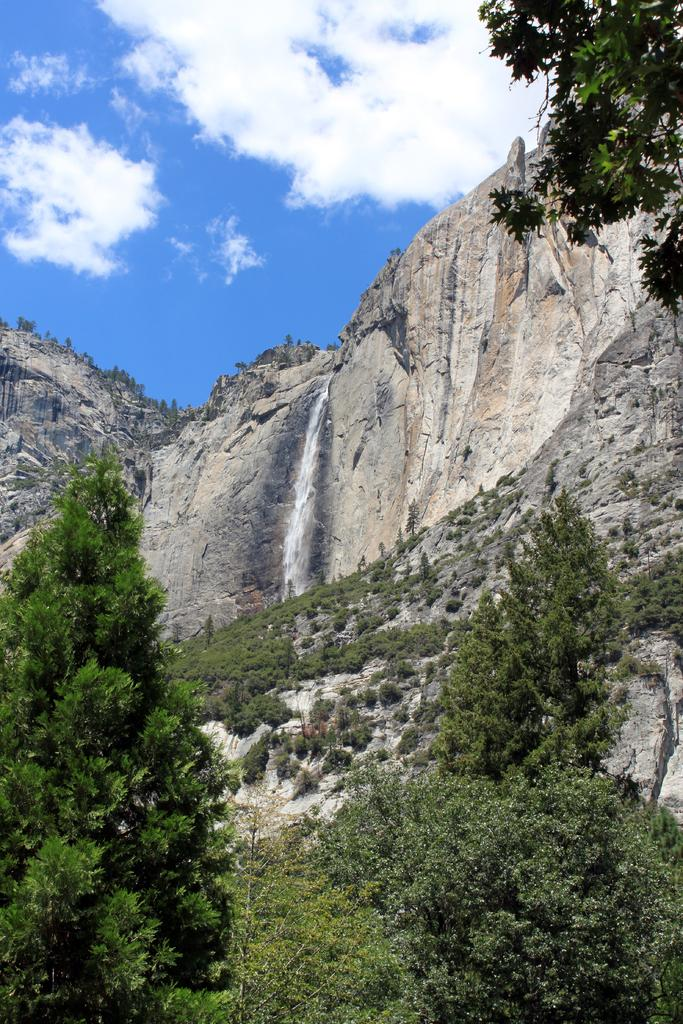What type of vegetation can be seen in the image? There are trees in the image. What geographical feature is present in the image? There is a mountain in the image. What is the condition of the sky in the image? The sky is clear in the image. Can you see any celery growing on the mountain in the image? There is no celery present in the image; it features trees and a mountain. What type of brush is used to paint the sky in the image? The image is a photograph, not a painting, so there is no brush used to create the sky. 